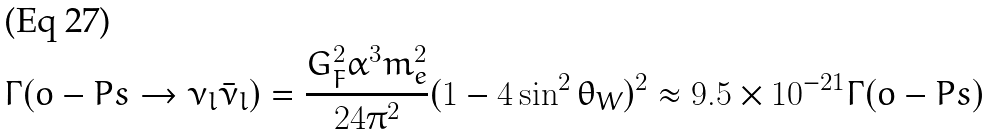<formula> <loc_0><loc_0><loc_500><loc_500>\Gamma ( o - P s \rightarrow \nu _ { l } \bar { \nu } _ { l } ) = \frac { G ^ { 2 } _ { F } \alpha ^ { 3 } m ^ { 2 } _ { e } } { 2 4 \pi ^ { 2 } } ( 1 - 4 \sin ^ { 2 } \theta _ { W } ) ^ { 2 } \approx 9 . 5 \times 1 0 ^ { - 2 1 } \Gamma ( o - P s )</formula> 